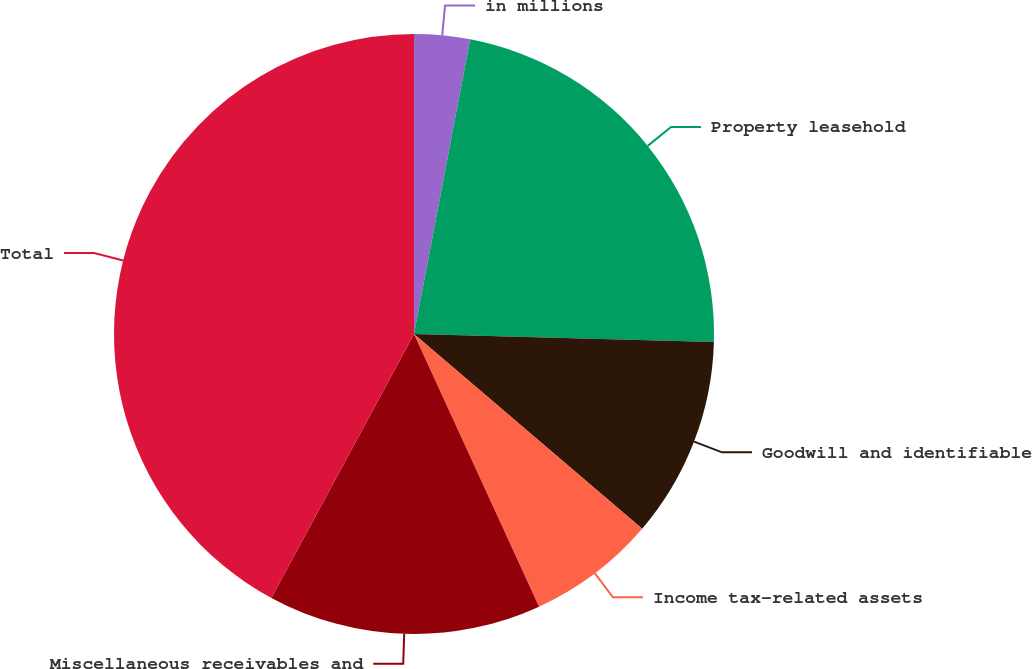Convert chart to OTSL. <chart><loc_0><loc_0><loc_500><loc_500><pie_chart><fcel>in millions<fcel>Property leasehold<fcel>Goodwill and identifiable<fcel>Income tax-related assets<fcel>Miscellaneous receivables and<fcel>Total<nl><fcel>3.0%<fcel>22.43%<fcel>10.82%<fcel>6.91%<fcel>14.73%<fcel>42.12%<nl></chart> 